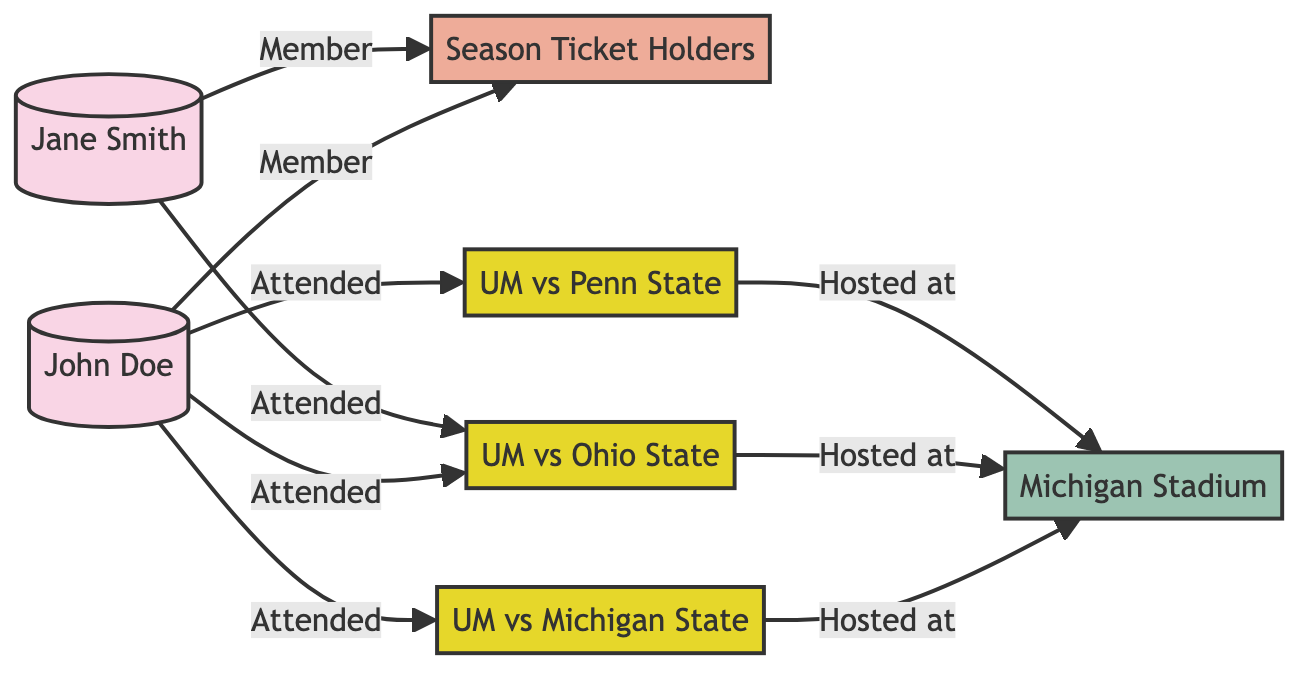What is the total number of nodes in the diagram? By counting the distinct entities in the diagram, we identify 7 nodes: John Doe, Jane Smith, Season Ticket Holders, two events (UM vs Ohio State, UM vs Michigan State, and UM vs Penn State), and Michigan Stadium.
Answer: 7 Who attended the event "University of Michigan vs Ohio State"? The diagram shows that both John Doe and Jane Smith have a direct relationship labeled "Attended" with the event "UM vs Ohio State".
Answer: John Doe, Jane Smith Which group do John Doe and Jane Smith belong to? Both individuals have a direct relationship labeled "Member" pointing to the node "Season Ticket Holders", indicating their membership in this group.
Answer: Season Ticket Holders How many events are hosted at Michigan Stadium? The diagram includes three events that are labeled as "Hosted at" Michigan Stadium, namely UM vs Ohio State, UM vs Michigan State, and UM vs Penn State.
Answer: 3 Which event occurs on November 25, 2023? The event "University of Michigan vs Ohio State" is associated with the date November 25, 2023, as indicated directly on the event node.
Answer: University of Michigan vs Ohio State Which node has the description "The Big House, home to University of Michigan football team"? The description matches the node labeled "Michigan Stadium", which is specifically described this way in the diagram.
Answer: Michigan Stadium How does John Doe connect to the "Season Ticket Holders"? John Doe has a direct relationship labeled "Member" leading to the node "Season Ticket Holders", showing his membership connection.
Answer: Member What relationship does John Doe have with the event "University of Michigan vs Michigan State"? The diagram shows a direct relationship labeled "Attended" between John Doe and the event "University of Michigan vs Michigan State," indicating he was present at that game.
Answer: Attended 